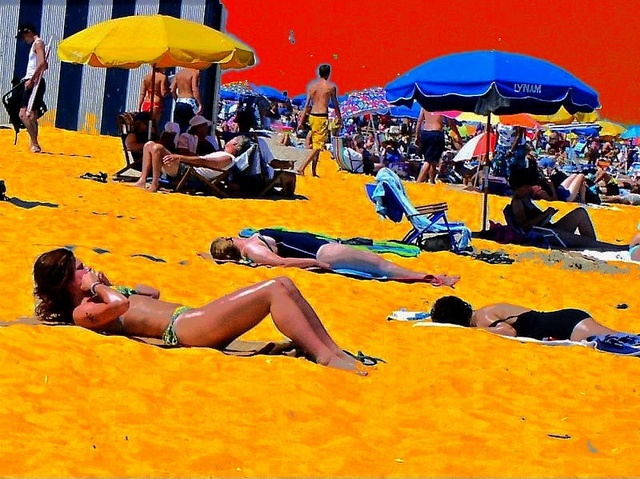Describe the objects in this image and their specific colors. I can see people in gray, black, salmon, brown, and maroon tones, umbrella in gray, blue, navy, and black tones, umbrella in gray, gold, brown, and maroon tones, people in gray, black, brown, and lightpink tones, and people in gray, black, salmon, tan, and navy tones in this image. 